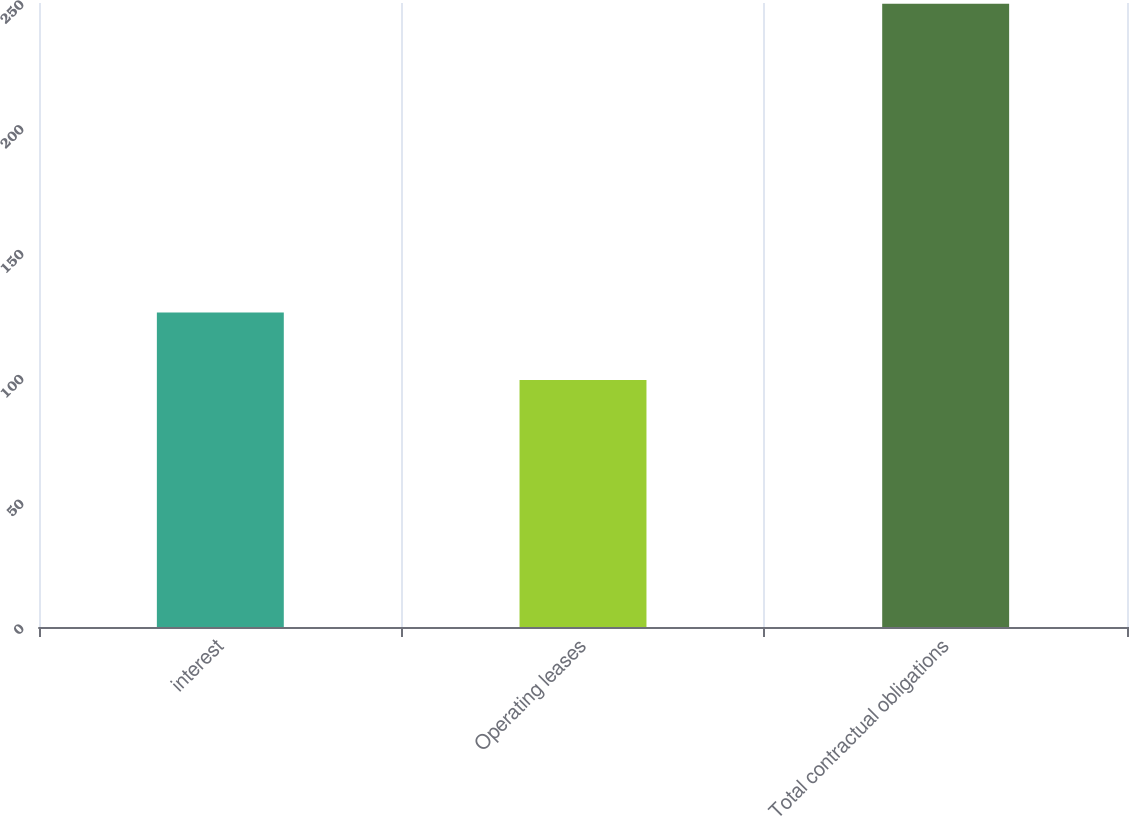Convert chart to OTSL. <chart><loc_0><loc_0><loc_500><loc_500><bar_chart><fcel>interest<fcel>Operating leases<fcel>Total contractual obligations<nl><fcel>126<fcel>99<fcel>249.7<nl></chart> 